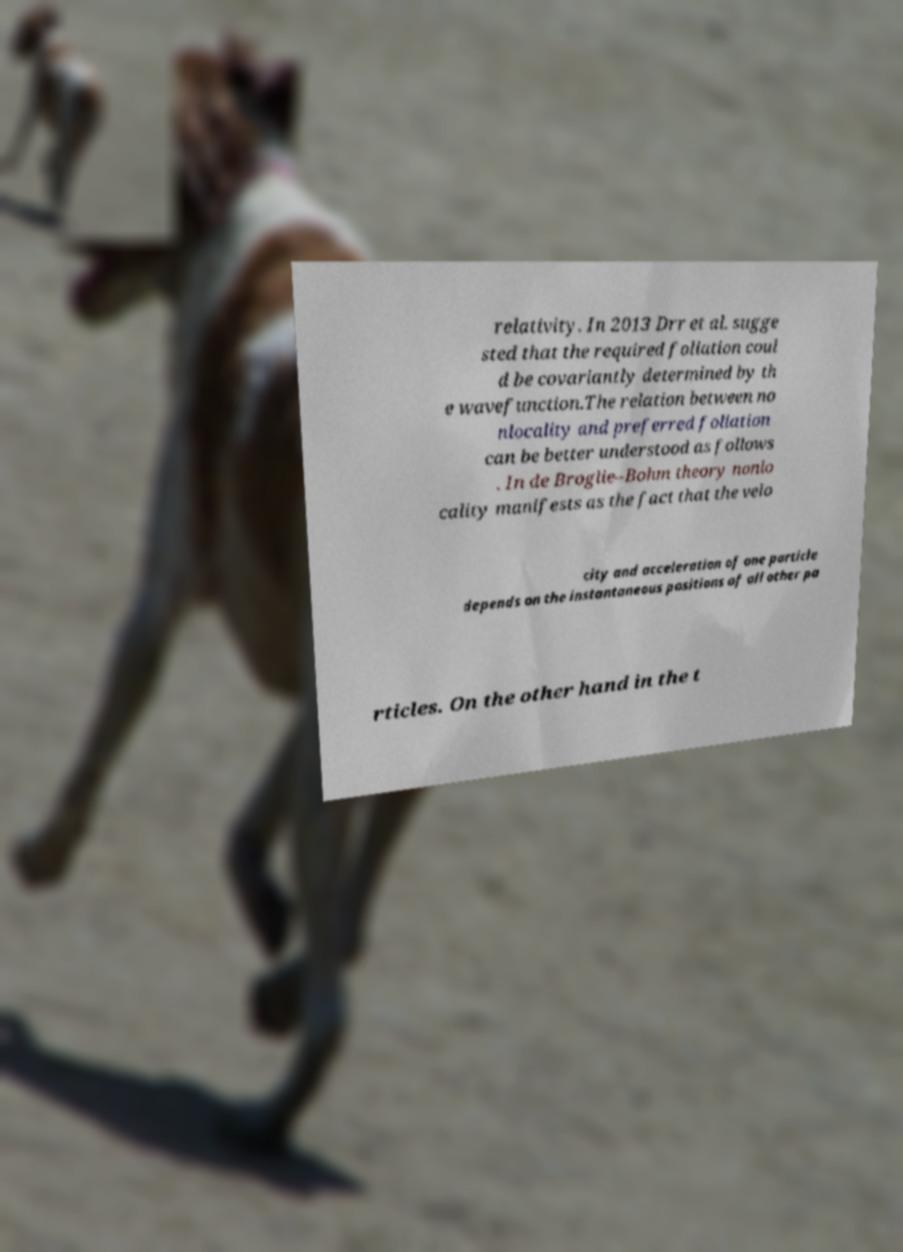Can you read and provide the text displayed in the image?This photo seems to have some interesting text. Can you extract and type it out for me? relativity. In 2013 Drr et al. sugge sted that the required foliation coul d be covariantly determined by th e wavefunction.The relation between no nlocality and preferred foliation can be better understood as follows . In de Broglie–Bohm theory nonlo cality manifests as the fact that the velo city and acceleration of one particle depends on the instantaneous positions of all other pa rticles. On the other hand in the t 